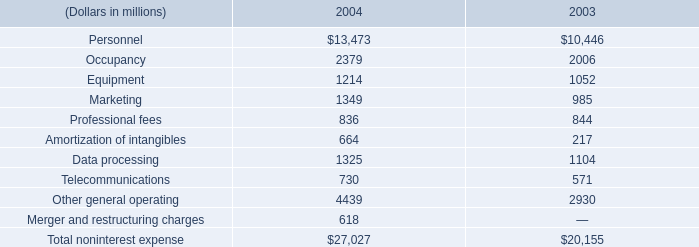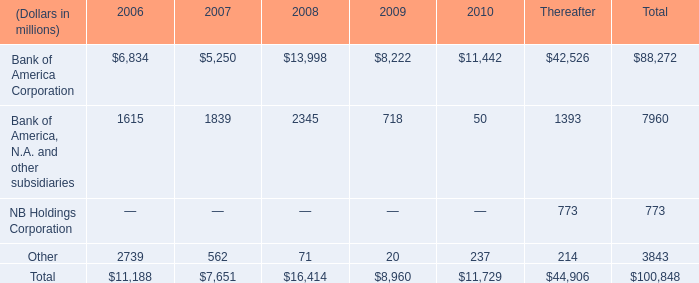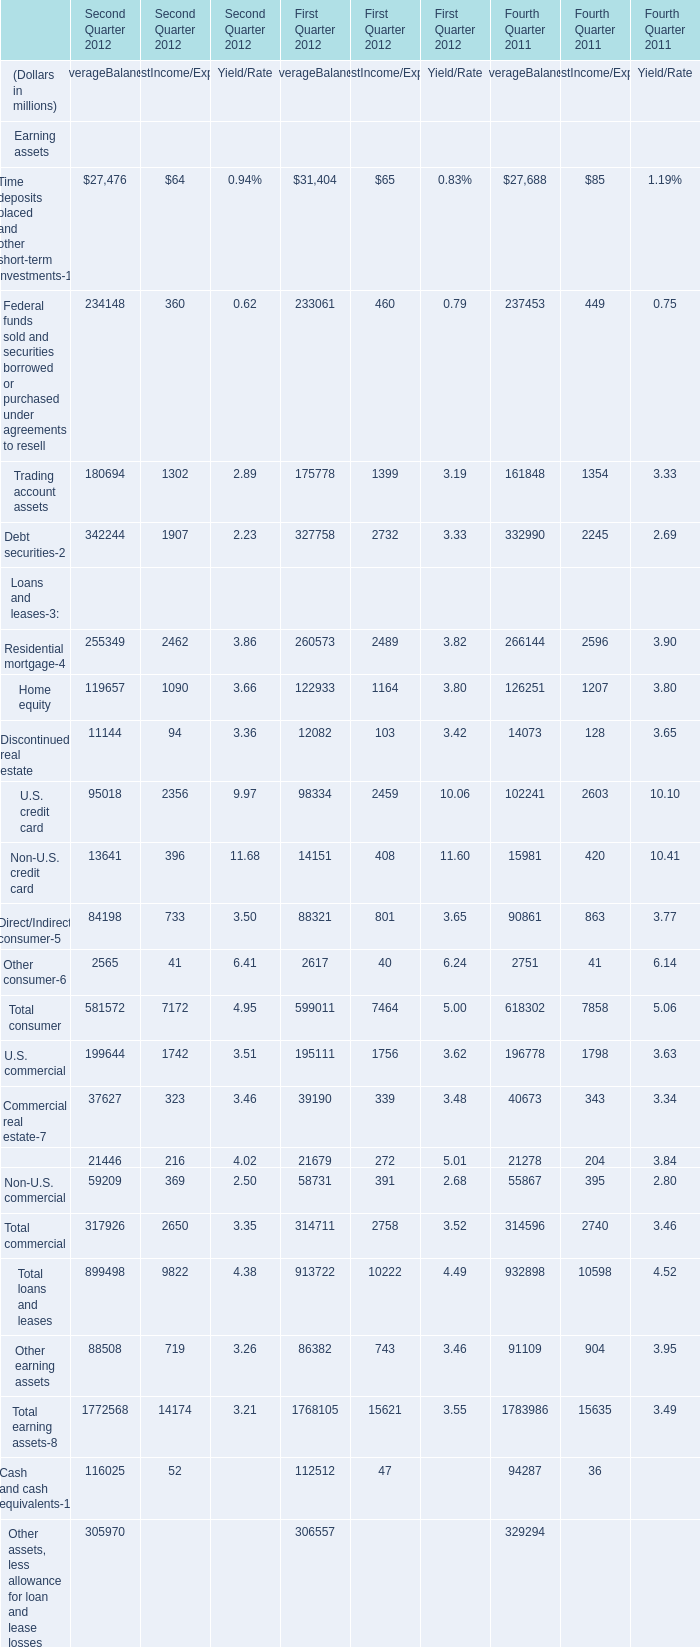What's the average of Bank of America, N.A. and other subsidiaries of Thereafter, and U.S. credit card of Second Quarter 2012 AverageBalance ? 
Computations: ((1393.0 + 95018.0) / 2)
Answer: 48205.5. 